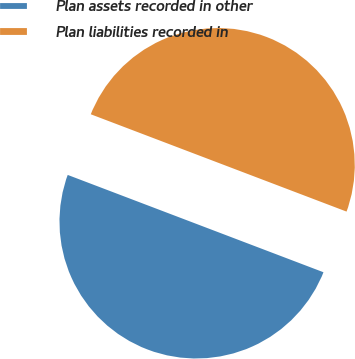Convert chart to OTSL. <chart><loc_0><loc_0><loc_500><loc_500><pie_chart><fcel>Plan assets recorded in other<fcel>Plan liabilities recorded in<nl><fcel>50.0%<fcel>50.0%<nl></chart> 